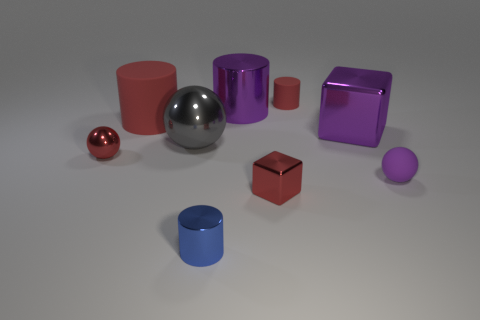Do the tiny rubber thing that is to the left of the purple block and the red rubber object that is in front of the large shiny cylinder have the same shape?
Provide a short and direct response. Yes. How many large things are there?
Make the answer very short. 4. There is a matte ball that is the same size as the blue object; what color is it?
Make the answer very short. Purple. Is the material of the small cylinder that is left of the purple cylinder the same as the big red cylinder that is left of the tiny blue shiny thing?
Offer a very short reply. No. What size is the block that is on the left side of the large purple metallic thing that is to the right of the large purple shiny cylinder?
Offer a very short reply. Small. What material is the ball right of the tiny blue metallic cylinder?
Keep it short and to the point. Rubber. How many things are either red rubber objects to the left of the red metallic cube or tiny red things left of the small block?
Provide a short and direct response. 2. There is a purple object that is the same shape as the gray thing; what is it made of?
Offer a terse response. Rubber. Is the color of the ball left of the big metallic ball the same as the matte cylinder that is in front of the tiny matte cylinder?
Offer a terse response. Yes. Are there any things that have the same size as the matte sphere?
Provide a short and direct response. Yes. 